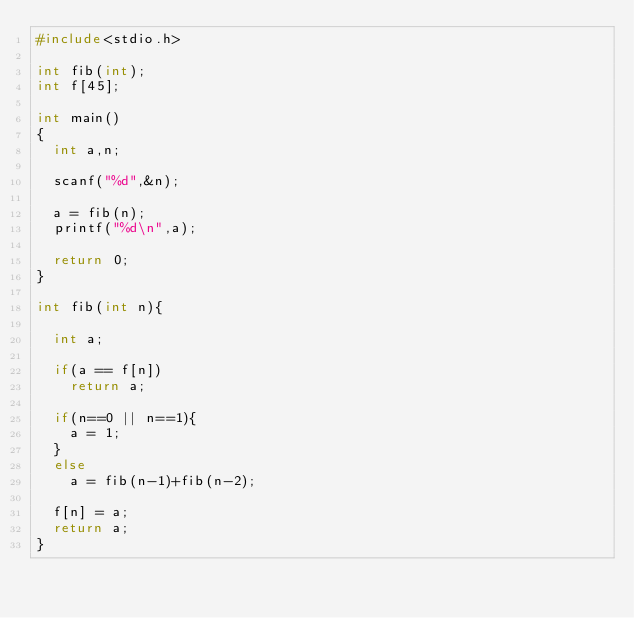<code> <loc_0><loc_0><loc_500><loc_500><_C_>#include<stdio.h>

int fib(int);
int f[45];

int main()
{
  int a,n;

  scanf("%d",&n);

  a = fib(n);
  printf("%d\n",a);

  return 0;
}

int fib(int n){

  int a;

  if(a == f[n])
    return a;
  
  if(n==0 || n==1){
    a = 1;
  }
  else
    a = fib(n-1)+fib(n-2);

  f[n] = a;
  return a;
}

</code> 